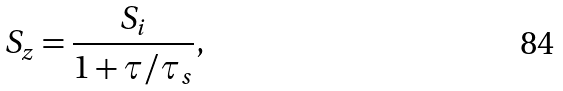Convert formula to latex. <formula><loc_0><loc_0><loc_500><loc_500>S _ { z } = \frac { S _ { i } } { 1 + \tau / \tau _ { s } } ,</formula> 